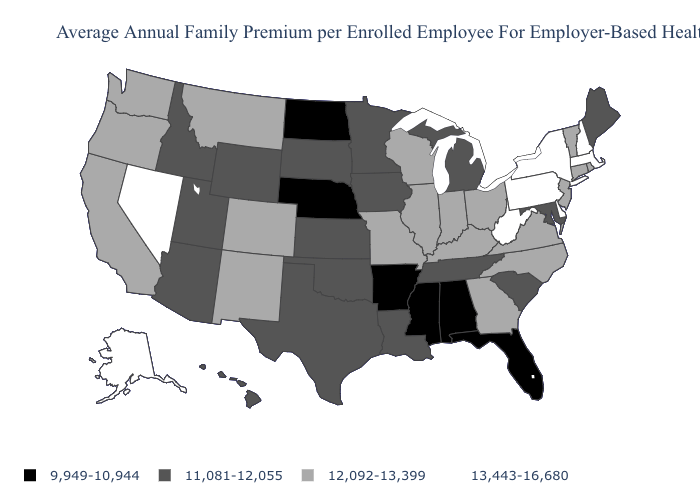Name the states that have a value in the range 13,443-16,680?
Give a very brief answer. Alaska, Delaware, Massachusetts, Nevada, New Hampshire, New York, Pennsylvania, West Virginia. Name the states that have a value in the range 13,443-16,680?
Be succinct. Alaska, Delaware, Massachusetts, Nevada, New Hampshire, New York, Pennsylvania, West Virginia. How many symbols are there in the legend?
Be succinct. 4. Among the states that border Idaho , does Utah have the lowest value?
Answer briefly. Yes. Among the states that border Alabama , which have the highest value?
Short answer required. Georgia. What is the value of Nevada?
Answer briefly. 13,443-16,680. What is the lowest value in the USA?
Give a very brief answer. 9,949-10,944. Which states hav the highest value in the West?
Answer briefly. Alaska, Nevada. Among the states that border Connecticut , does Massachusetts have the highest value?
Short answer required. Yes. What is the value of Oregon?
Quick response, please. 12,092-13,399. What is the value of Virginia?
Be succinct. 12,092-13,399. Does Hawaii have the lowest value in the West?
Answer briefly. Yes. What is the value of Arizona?
Be succinct. 11,081-12,055. Does the map have missing data?
Short answer required. No. Among the states that border Utah , which have the highest value?
Answer briefly. Nevada. 